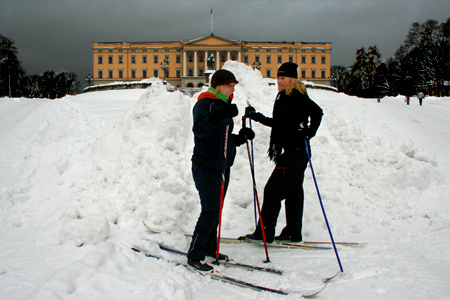If the snow suddenly melted, how do you think this scene would change? If the snow suddenly melted, the scene would become quite different. The white snow-covered ground would turn grassy or muddy, depending on the weather conditions and the underlying ground. The individuals would have to abandon their skiing activity, possibly opting for a walk or finding another outdoor pursuit suitable for a snow-free environment. The dark, overcast sky might still loom above, casting a serene or gloomy atmosphere over the now vibrant or wet landscape. 